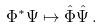Convert formula to latex. <formula><loc_0><loc_0><loc_500><loc_500>\Phi ^ { * } \Psi \mapsto \hat { \Phi } \hat { \Psi } \, .</formula> 